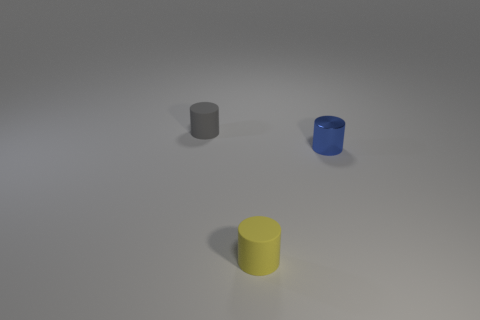Add 1 blue shiny things. How many objects exist? 4 Subtract 0 green blocks. How many objects are left? 3 Subtract all small gray things. Subtract all gray matte objects. How many objects are left? 1 Add 1 small gray cylinders. How many small gray cylinders are left? 2 Add 1 small yellow matte cylinders. How many small yellow matte cylinders exist? 2 